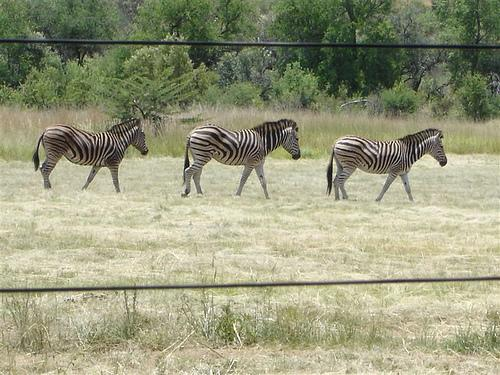How many zebra are walking in a line behind the fence? three 